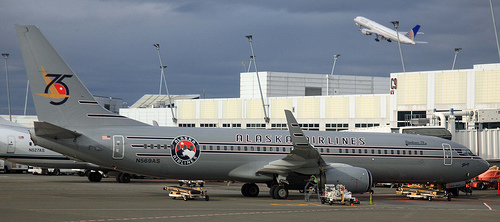Could this place be the train station?
Answer the question using a single word or phrase. No Is there any closed window or door? Yes Does the door look open? No Are there birds in this photograph? No 